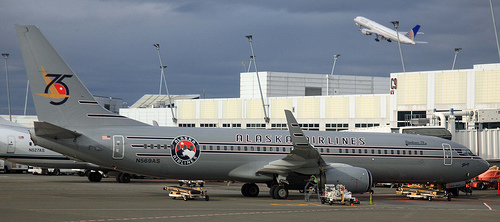Could this place be the train station?
Answer the question using a single word or phrase. No Is there any closed window or door? Yes Does the door look open? No Are there birds in this photograph? No 